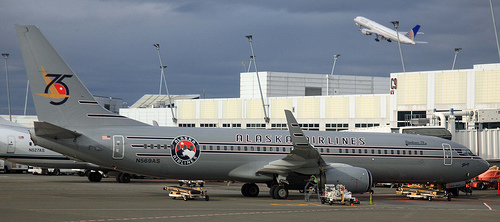Could this place be the train station?
Answer the question using a single word or phrase. No Is there any closed window or door? Yes Does the door look open? No Are there birds in this photograph? No 